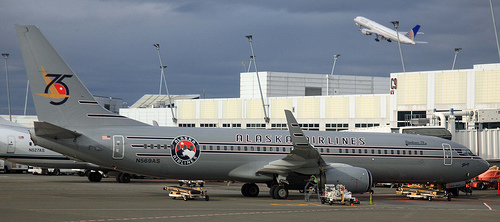Could this place be the train station?
Answer the question using a single word or phrase. No Is there any closed window or door? Yes Does the door look open? No Are there birds in this photograph? No 